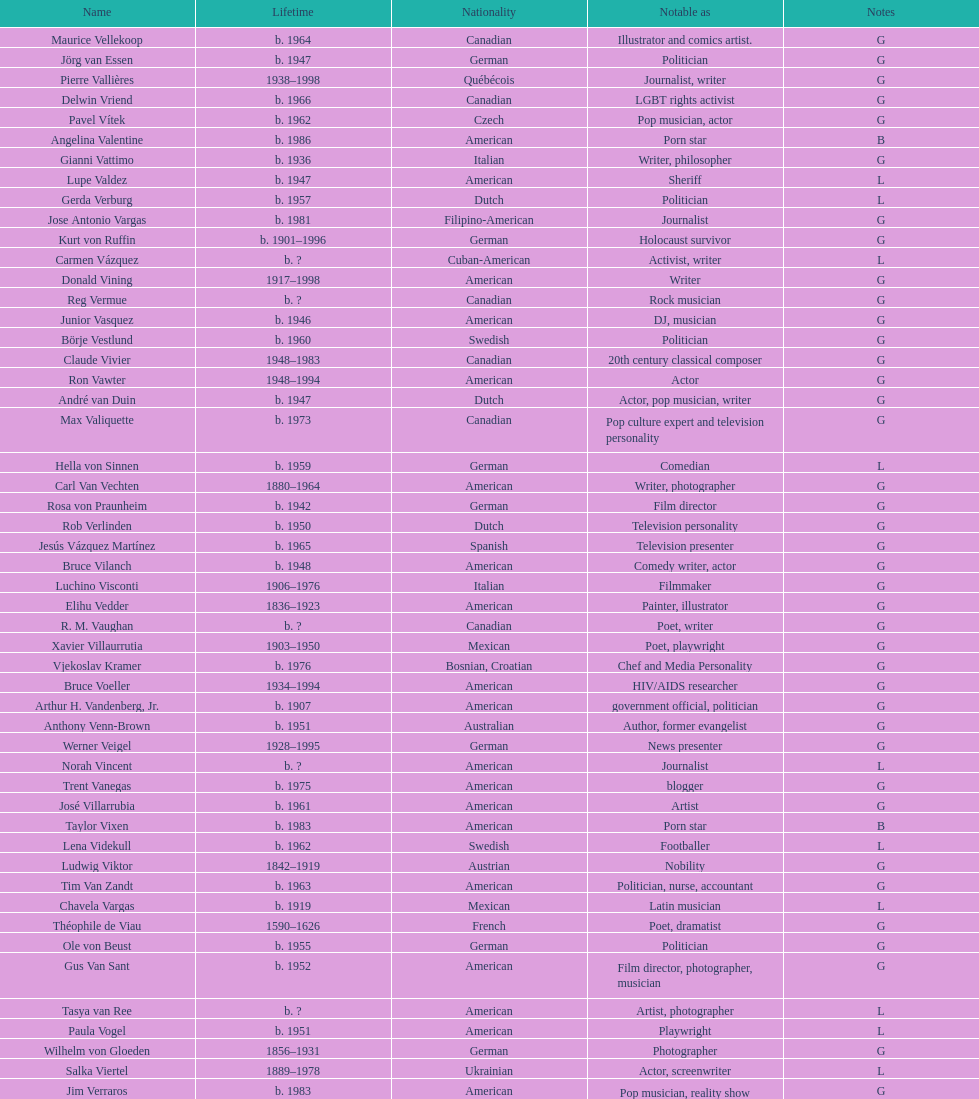Which nationality has the most people associated with it? American. 